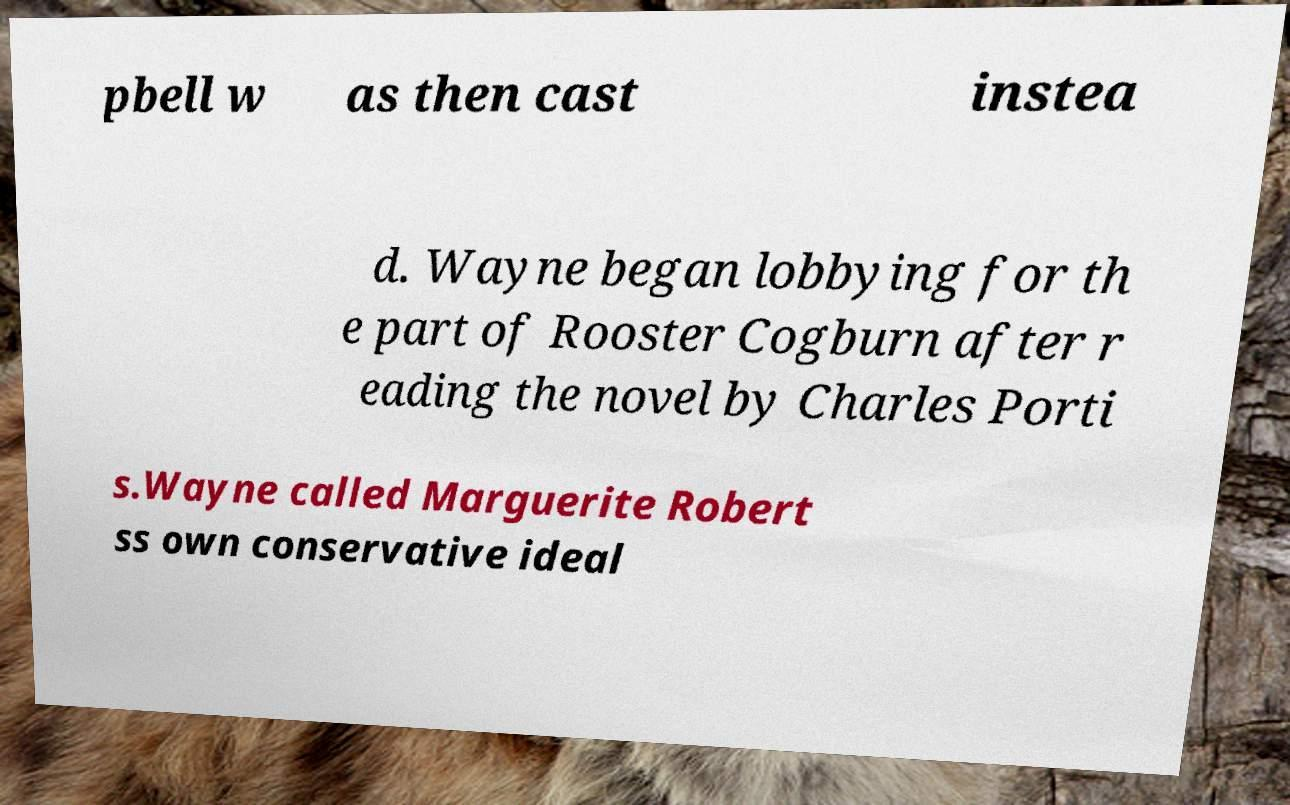There's text embedded in this image that I need extracted. Can you transcribe it verbatim? pbell w as then cast instea d. Wayne began lobbying for th e part of Rooster Cogburn after r eading the novel by Charles Porti s.Wayne called Marguerite Robert ss own conservative ideal 